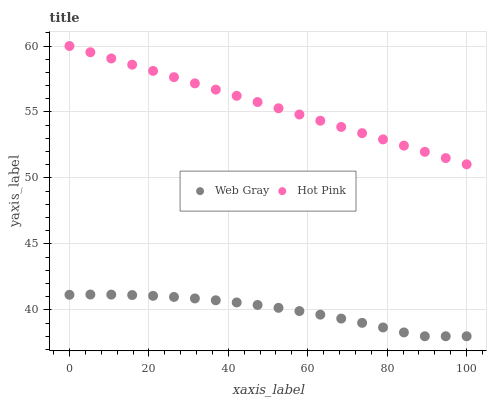Does Web Gray have the minimum area under the curve?
Answer yes or no. Yes. Does Hot Pink have the maximum area under the curve?
Answer yes or no. Yes. Does Hot Pink have the minimum area under the curve?
Answer yes or no. No. Is Hot Pink the smoothest?
Answer yes or no. Yes. Is Web Gray the roughest?
Answer yes or no. Yes. Is Hot Pink the roughest?
Answer yes or no. No. Does Web Gray have the lowest value?
Answer yes or no. Yes. Does Hot Pink have the lowest value?
Answer yes or no. No. Does Hot Pink have the highest value?
Answer yes or no. Yes. Is Web Gray less than Hot Pink?
Answer yes or no. Yes. Is Hot Pink greater than Web Gray?
Answer yes or no. Yes. Does Web Gray intersect Hot Pink?
Answer yes or no. No. 